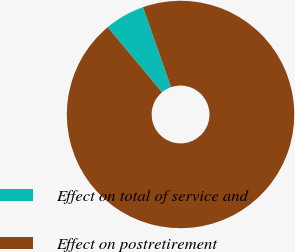Convert chart. <chart><loc_0><loc_0><loc_500><loc_500><pie_chart><fcel>Effect on total of service and<fcel>Effect on postretirement<nl><fcel>5.71%<fcel>94.29%<nl></chart> 